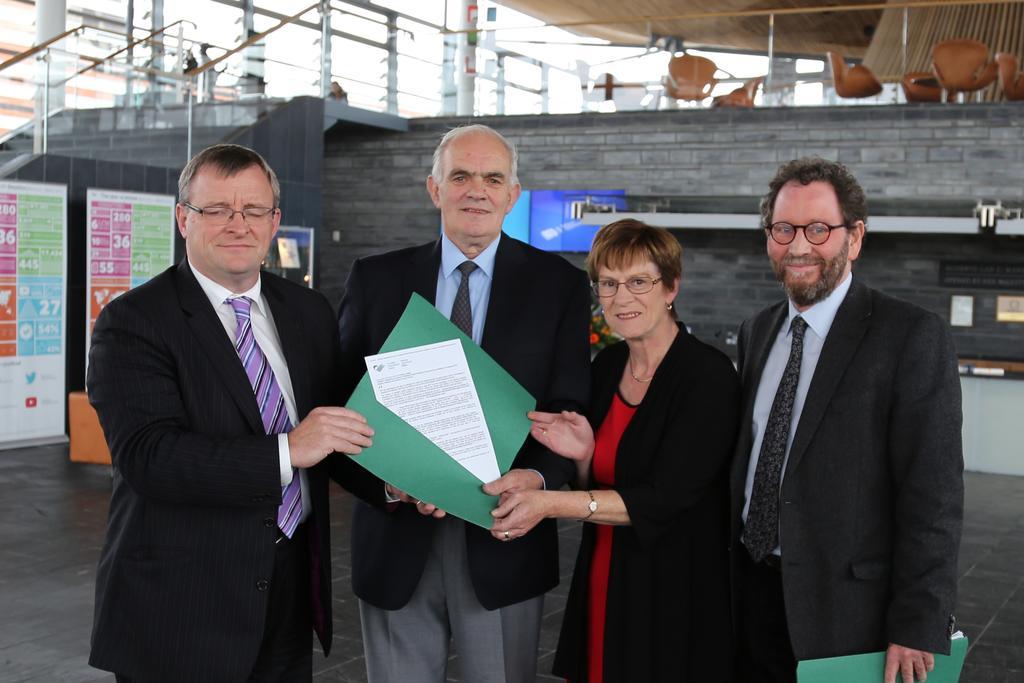Could you give a brief overview of what you see in this image? In this image there are three man and a women, two men and a woman are holding a file in their hands, in the background there is a wall on top of that there are chairs, steps, beside that there are posters, on that posters there is some text. 